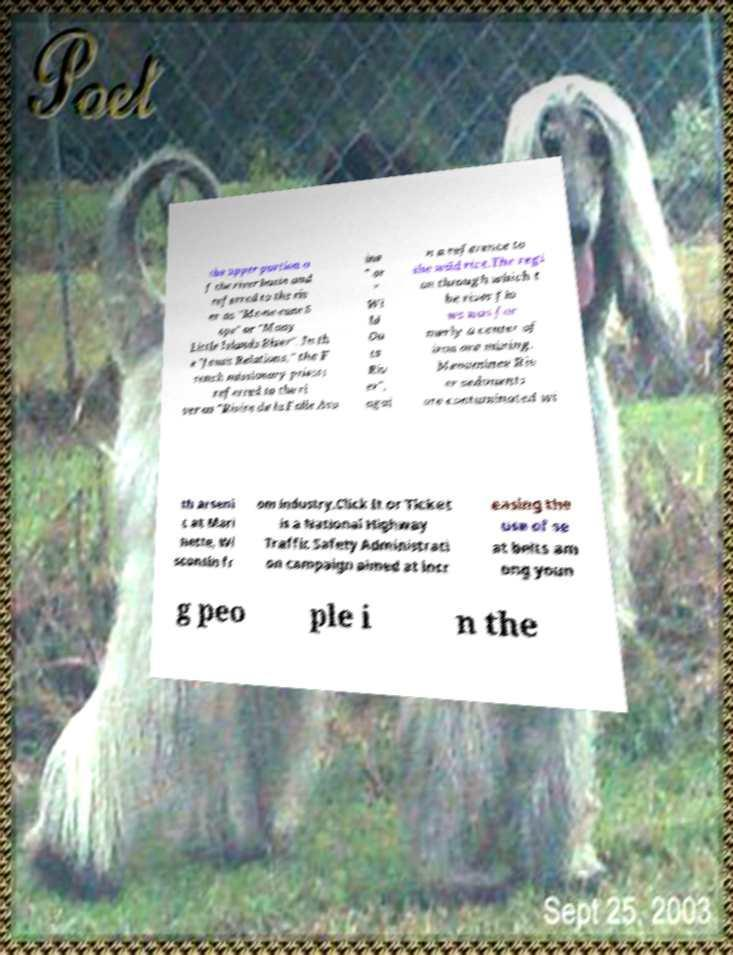Could you assist in decoding the text presented in this image and type it out clearly? the upper portion o f the river basin and referred to the riv er as "Me-ne-cane S epe" or "Many Little Islands River". In th e "Jesuit Relations," the F rench missionary priests referred to the ri ver as "Rivire de la Folle Avo ine " or " Wi ld Oa ts Riv er", agai n a reference to the wild rice.The regi on through which t he river flo ws was for merly a center of iron ore mining. Menominee Riv er sediments are contaminated wi th arseni c at Mari nette, Wi sconsin fr om industry.Click It or Ticket is a National Highway Traffic Safety Administrati on campaign aimed at incr easing the use of se at belts am ong youn g peo ple i n the 